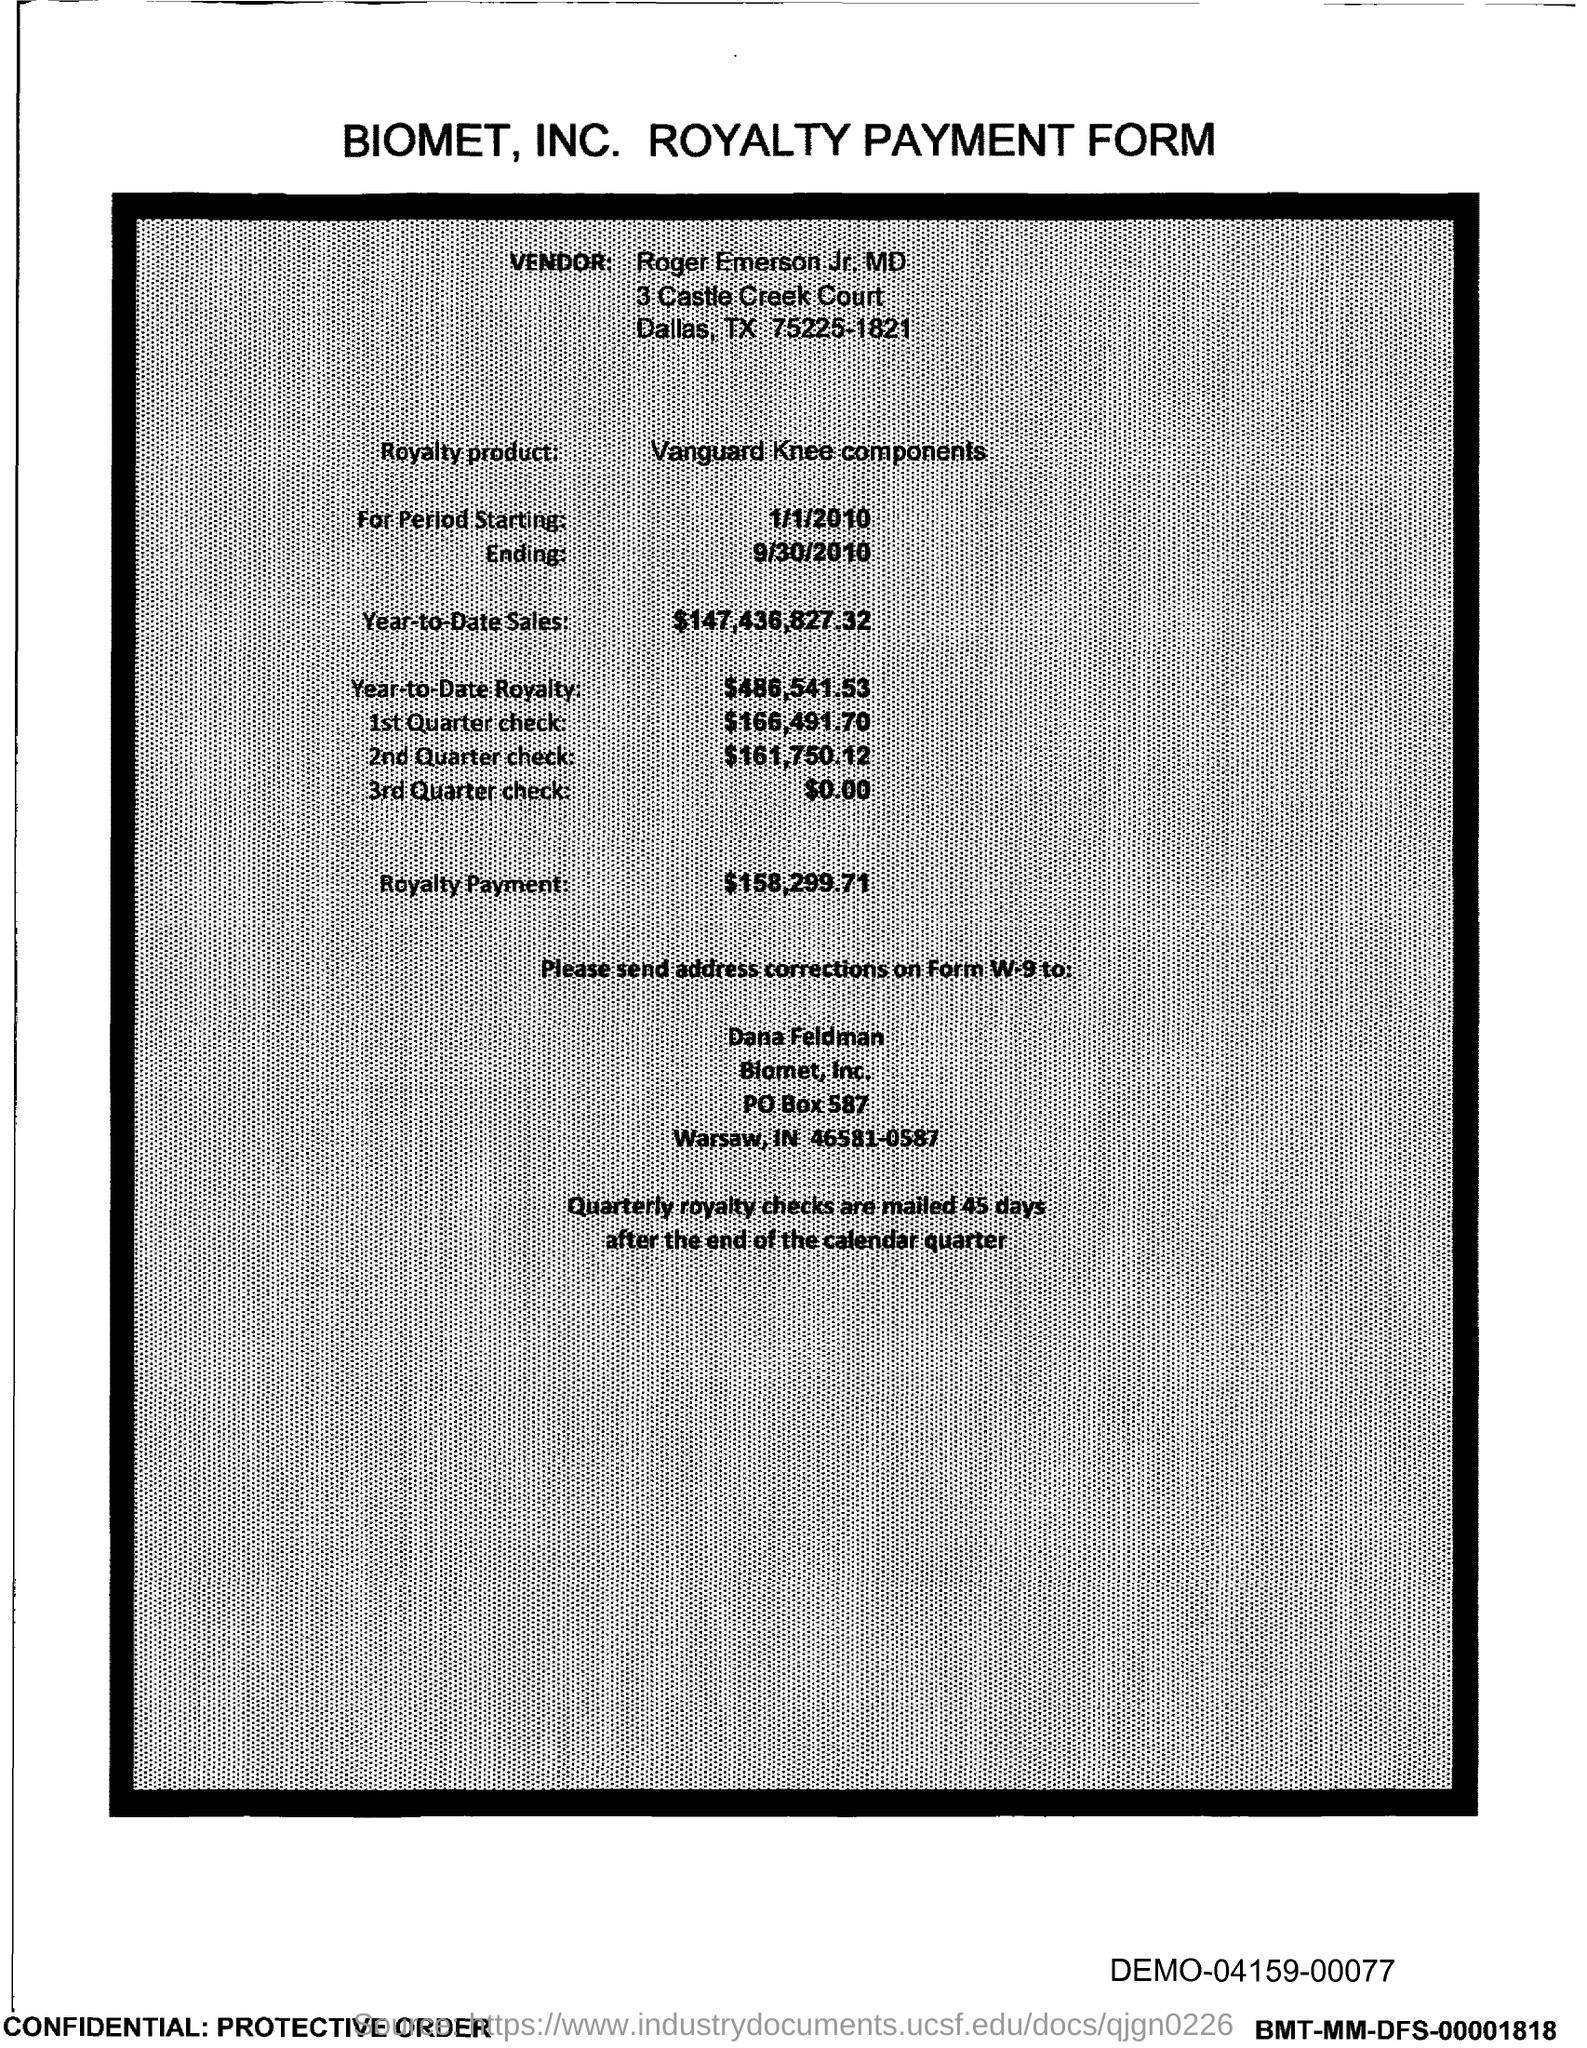List a handful of essential elements in this visual. The amount of the 1st quarter check mentioned in the form is $166,491.70. The amount of the 3rd Quarter check given in the form is zero dollars and zero cents. This royalty payment form belongs to Biomet, Inc. Roger Emerson Jr, MD, is the vendor mentioned in the form. The year-to-date sales for the royalty product are 147,436,827,323. 